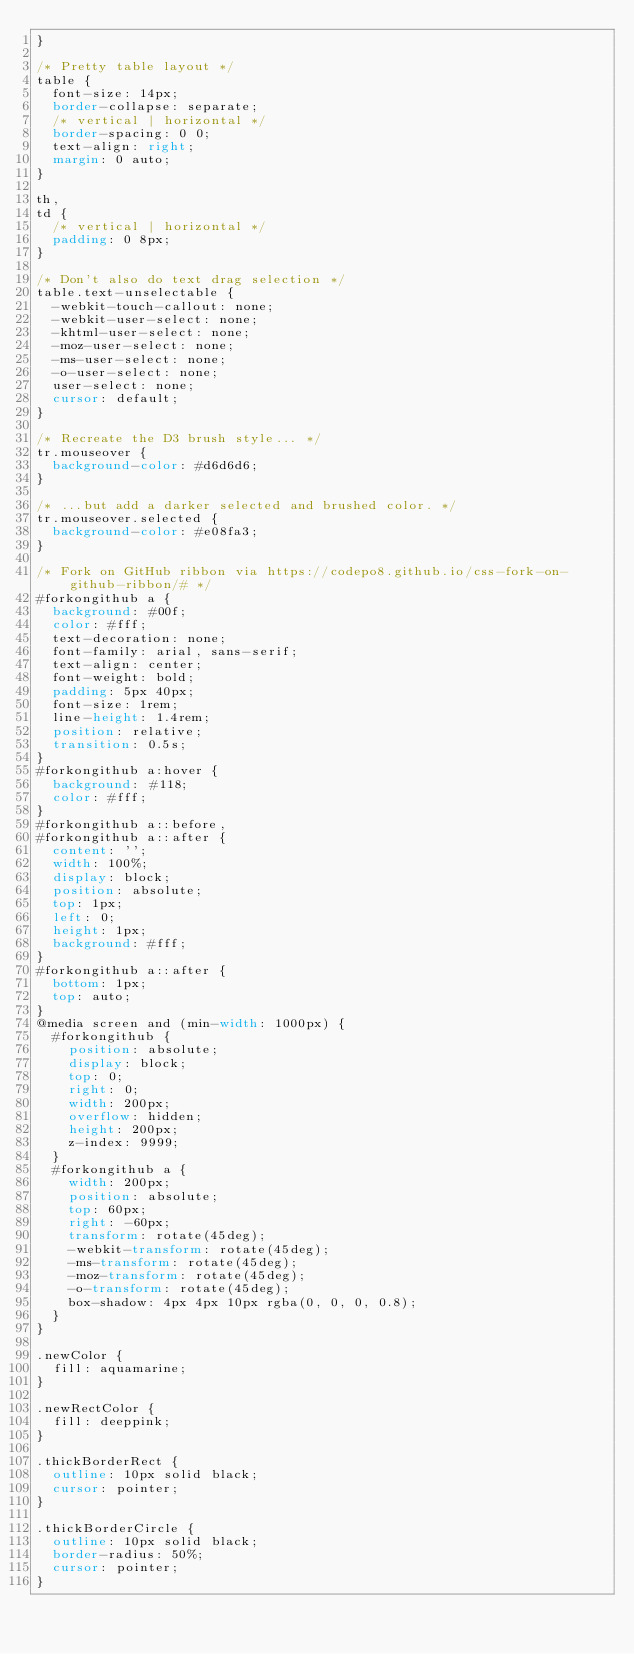Convert code to text. <code><loc_0><loc_0><loc_500><loc_500><_CSS_>}

/* Pretty table layout */
table {
  font-size: 14px;
  border-collapse: separate;
  /* vertical | horizontal */
  border-spacing: 0 0;
  text-align: right;
  margin: 0 auto;
}

th,
td {
  /* vertical | horizontal */
  padding: 0 8px;
}

/* Don't also do text drag selection */
table.text-unselectable {
  -webkit-touch-callout: none;
  -webkit-user-select: none;
  -khtml-user-select: none;
  -moz-user-select: none;
  -ms-user-select: none;
  -o-user-select: none;
  user-select: none;
  cursor: default;
}

/* Recreate the D3 brush style... */
tr.mouseover {
  background-color: #d6d6d6;
}

/* ...but add a darker selected and brushed color. */
tr.mouseover.selected {
  background-color: #e08fa3;
}

/* Fork on GitHub ribbon via https://codepo8.github.io/css-fork-on-github-ribbon/# */
#forkongithub a {
  background: #00f;
  color: #fff;
  text-decoration: none;
  font-family: arial, sans-serif;
  text-align: center;
  font-weight: bold;
  padding: 5px 40px;
  font-size: 1rem;
  line-height: 1.4rem;
  position: relative;
  transition: 0.5s;
}
#forkongithub a:hover {
  background: #118;
  color: #fff;
}
#forkongithub a::before,
#forkongithub a::after {
  content: '';
  width: 100%;
  display: block;
  position: absolute;
  top: 1px;
  left: 0;
  height: 1px;
  background: #fff;
}
#forkongithub a::after {
  bottom: 1px;
  top: auto;
}
@media screen and (min-width: 1000px) {
  #forkongithub {
    position: absolute;
    display: block;
    top: 0;
    right: 0;
    width: 200px;
    overflow: hidden;
    height: 200px;
    z-index: 9999;
  }
  #forkongithub a {
    width: 200px;
    position: absolute;
    top: 60px;
    right: -60px;
    transform: rotate(45deg);
    -webkit-transform: rotate(45deg);
    -ms-transform: rotate(45deg);
    -moz-transform: rotate(45deg);
    -o-transform: rotate(45deg);
    box-shadow: 4px 4px 10px rgba(0, 0, 0, 0.8);
  }
}

.newColor {
  fill: aquamarine;
}

.newRectColor {
  fill: deeppink;
}

.thickBorderRect {
  outline: 10px solid black;
  cursor: pointer;
}

.thickBorderCircle {
  outline: 10px solid black;
  border-radius: 50%;
  cursor: pointer;
}
</code> 